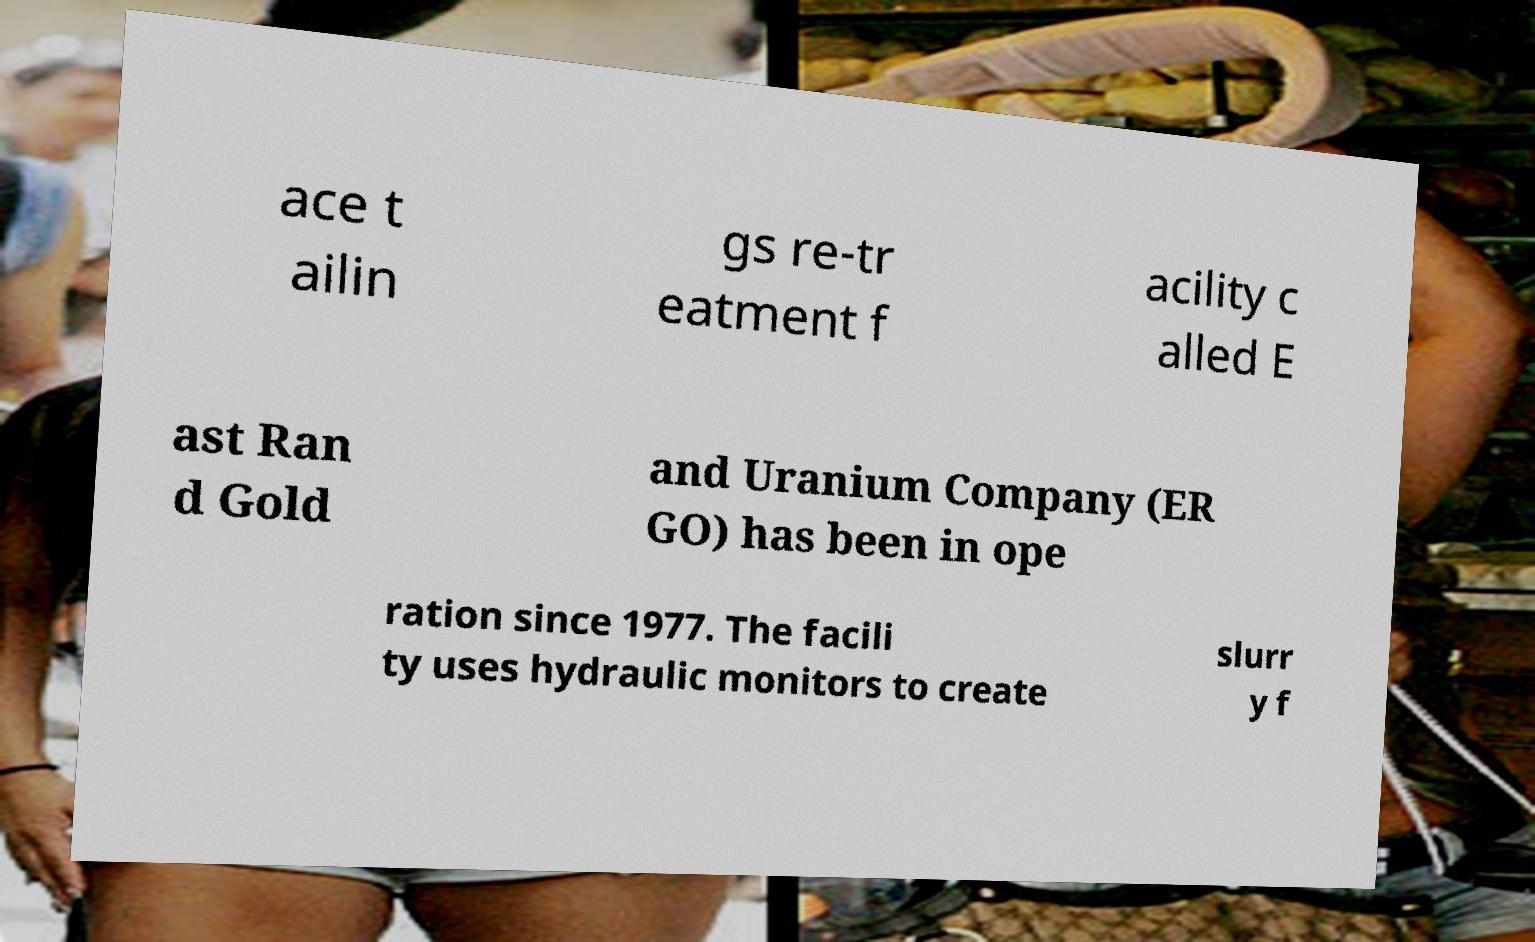Can you read and provide the text displayed in the image?This photo seems to have some interesting text. Can you extract and type it out for me? ace t ailin gs re-tr eatment f acility c alled E ast Ran d Gold and Uranium Company (ER GO) has been in ope ration since 1977. The facili ty uses hydraulic monitors to create slurr y f 